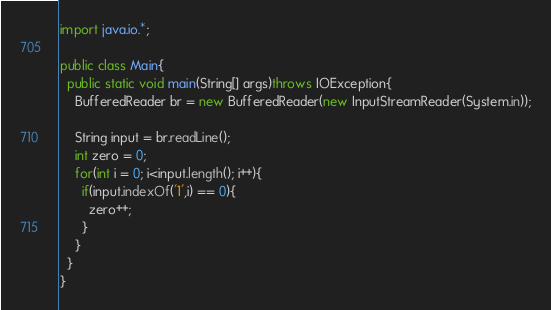Convert code to text. <code><loc_0><loc_0><loc_500><loc_500><_Java_>import java.io.*;
 
public class Main{
  public static void main(String[] args)throws IOException{
    BufferedReader br = new BufferedReader(new InputStreamReader(System.in));
    
    String input = br.readLine();
    int zero = 0;
    for(int i = 0; i<input.length(); i++){
      if(input.indexOf('1',i) == 0){
        zero++;
      }
    }
  }
}</code> 